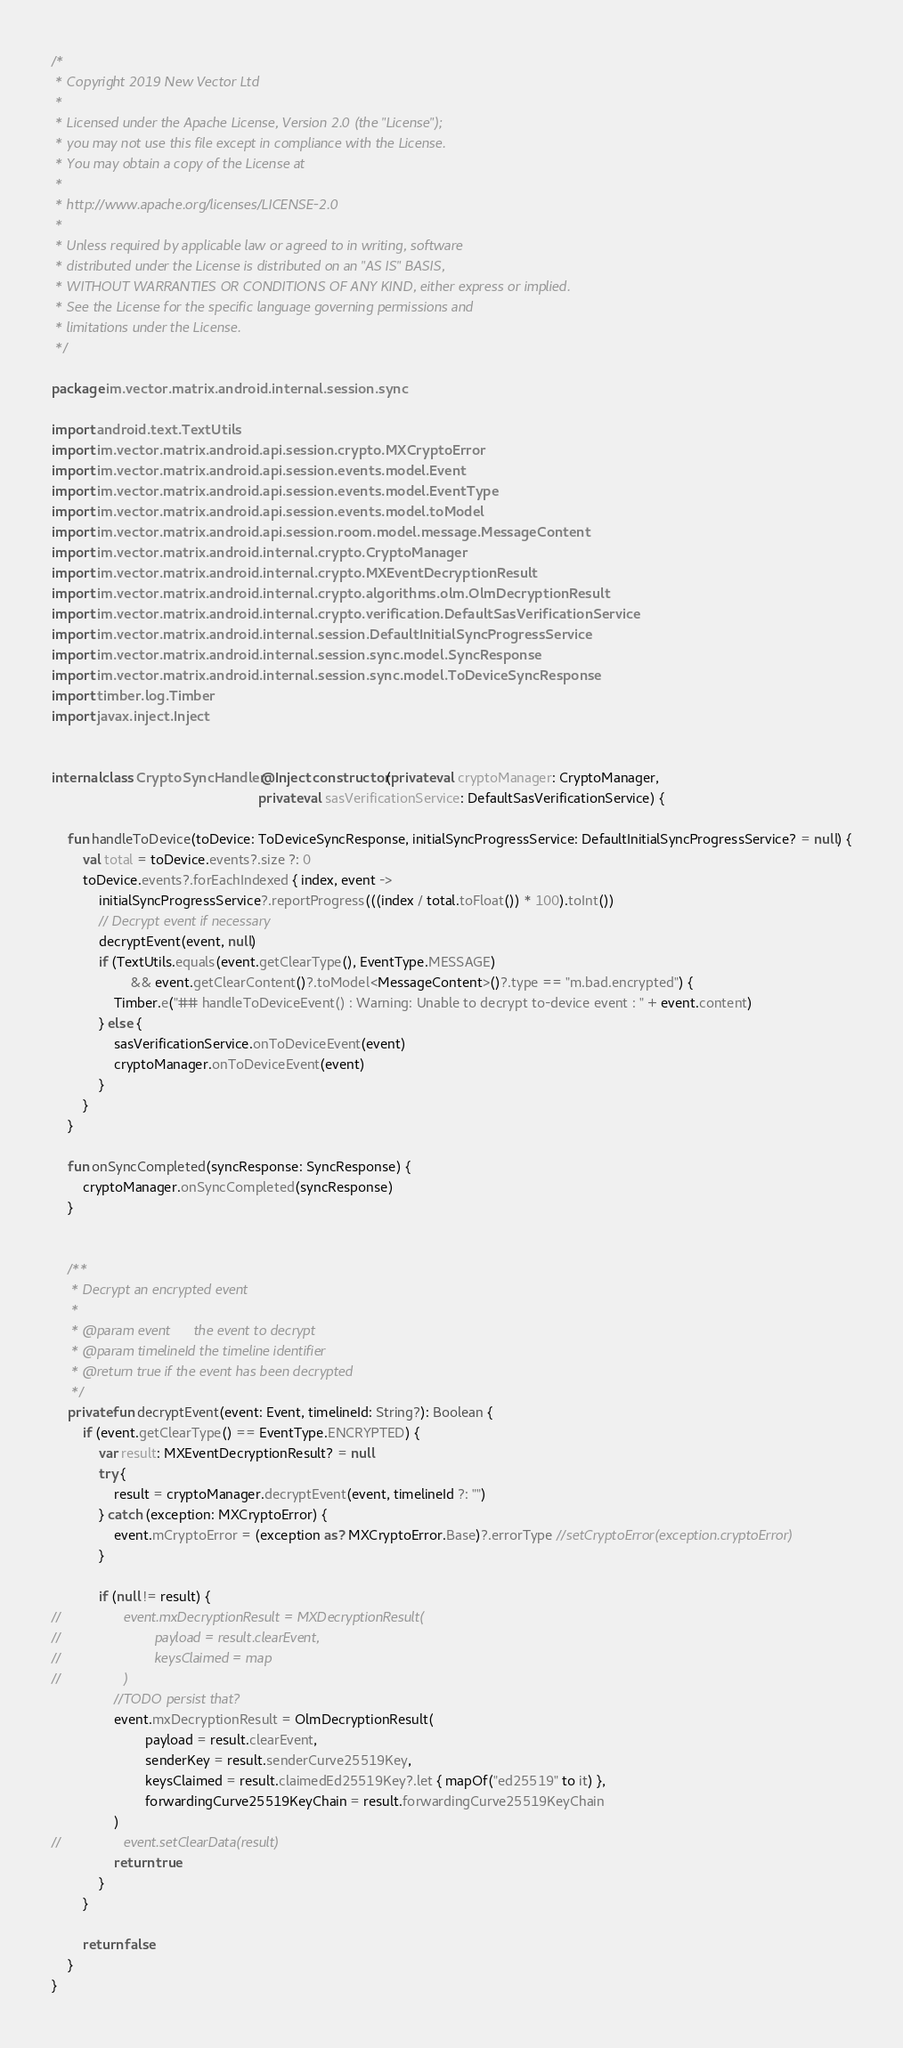Convert code to text. <code><loc_0><loc_0><loc_500><loc_500><_Kotlin_>/*
 * Copyright 2019 New Vector Ltd
 *
 * Licensed under the Apache License, Version 2.0 (the "License");
 * you may not use this file except in compliance with the License.
 * You may obtain a copy of the License at
 *
 * http://www.apache.org/licenses/LICENSE-2.0
 *
 * Unless required by applicable law or agreed to in writing, software
 * distributed under the License is distributed on an "AS IS" BASIS,
 * WITHOUT WARRANTIES OR CONDITIONS OF ANY KIND, either express or implied.
 * See the License for the specific language governing permissions and
 * limitations under the License.
 */

package im.vector.matrix.android.internal.session.sync

import android.text.TextUtils
import im.vector.matrix.android.api.session.crypto.MXCryptoError
import im.vector.matrix.android.api.session.events.model.Event
import im.vector.matrix.android.api.session.events.model.EventType
import im.vector.matrix.android.api.session.events.model.toModel
import im.vector.matrix.android.api.session.room.model.message.MessageContent
import im.vector.matrix.android.internal.crypto.CryptoManager
import im.vector.matrix.android.internal.crypto.MXEventDecryptionResult
import im.vector.matrix.android.internal.crypto.algorithms.olm.OlmDecryptionResult
import im.vector.matrix.android.internal.crypto.verification.DefaultSasVerificationService
import im.vector.matrix.android.internal.session.DefaultInitialSyncProgressService
import im.vector.matrix.android.internal.session.sync.model.SyncResponse
import im.vector.matrix.android.internal.session.sync.model.ToDeviceSyncResponse
import timber.log.Timber
import javax.inject.Inject


internal class CryptoSyncHandler @Inject constructor(private val cryptoManager: CryptoManager,
                                                     private val sasVerificationService: DefaultSasVerificationService) {

    fun handleToDevice(toDevice: ToDeviceSyncResponse, initialSyncProgressService: DefaultInitialSyncProgressService? = null) {
        val total = toDevice.events?.size ?: 0
        toDevice.events?.forEachIndexed { index, event ->
            initialSyncProgressService?.reportProgress(((index / total.toFloat()) * 100).toInt())
            // Decrypt event if necessary
            decryptEvent(event, null)
            if (TextUtils.equals(event.getClearType(), EventType.MESSAGE)
                    && event.getClearContent()?.toModel<MessageContent>()?.type == "m.bad.encrypted") {
                Timber.e("## handleToDeviceEvent() : Warning: Unable to decrypt to-device event : " + event.content)
            } else {
                sasVerificationService.onToDeviceEvent(event)
                cryptoManager.onToDeviceEvent(event)
            }
        }
    }

    fun onSyncCompleted(syncResponse: SyncResponse) {
        cryptoManager.onSyncCompleted(syncResponse)
    }


    /**
     * Decrypt an encrypted event
     *
     * @param event      the event to decrypt
     * @param timelineId the timeline identifier
     * @return true if the event has been decrypted
     */
    private fun decryptEvent(event: Event, timelineId: String?): Boolean {
        if (event.getClearType() == EventType.ENCRYPTED) {
            var result: MXEventDecryptionResult? = null
            try {
                result = cryptoManager.decryptEvent(event, timelineId ?: "")
            } catch (exception: MXCryptoError) {
                event.mCryptoError = (exception as? MXCryptoError.Base)?.errorType //setCryptoError(exception.cryptoError)
            }

            if (null != result) {
//                event.mxDecryptionResult = MXDecryptionResult(
//                        payload = result.clearEvent,
//                        keysClaimed = map
//                )
                //TODO persist that?
                event.mxDecryptionResult = OlmDecryptionResult(
                        payload = result.clearEvent,
                        senderKey = result.senderCurve25519Key,
                        keysClaimed = result.claimedEd25519Key?.let { mapOf("ed25519" to it) },
                        forwardingCurve25519KeyChain = result.forwardingCurve25519KeyChain
                )
//                event.setClearData(result)
                return true
            }
        }

        return false
    }
}</code> 